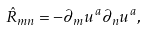<formula> <loc_0><loc_0><loc_500><loc_500>\hat { R } _ { m n } = - \partial _ { m } u ^ { a } \partial _ { n } u ^ { a } ,</formula> 